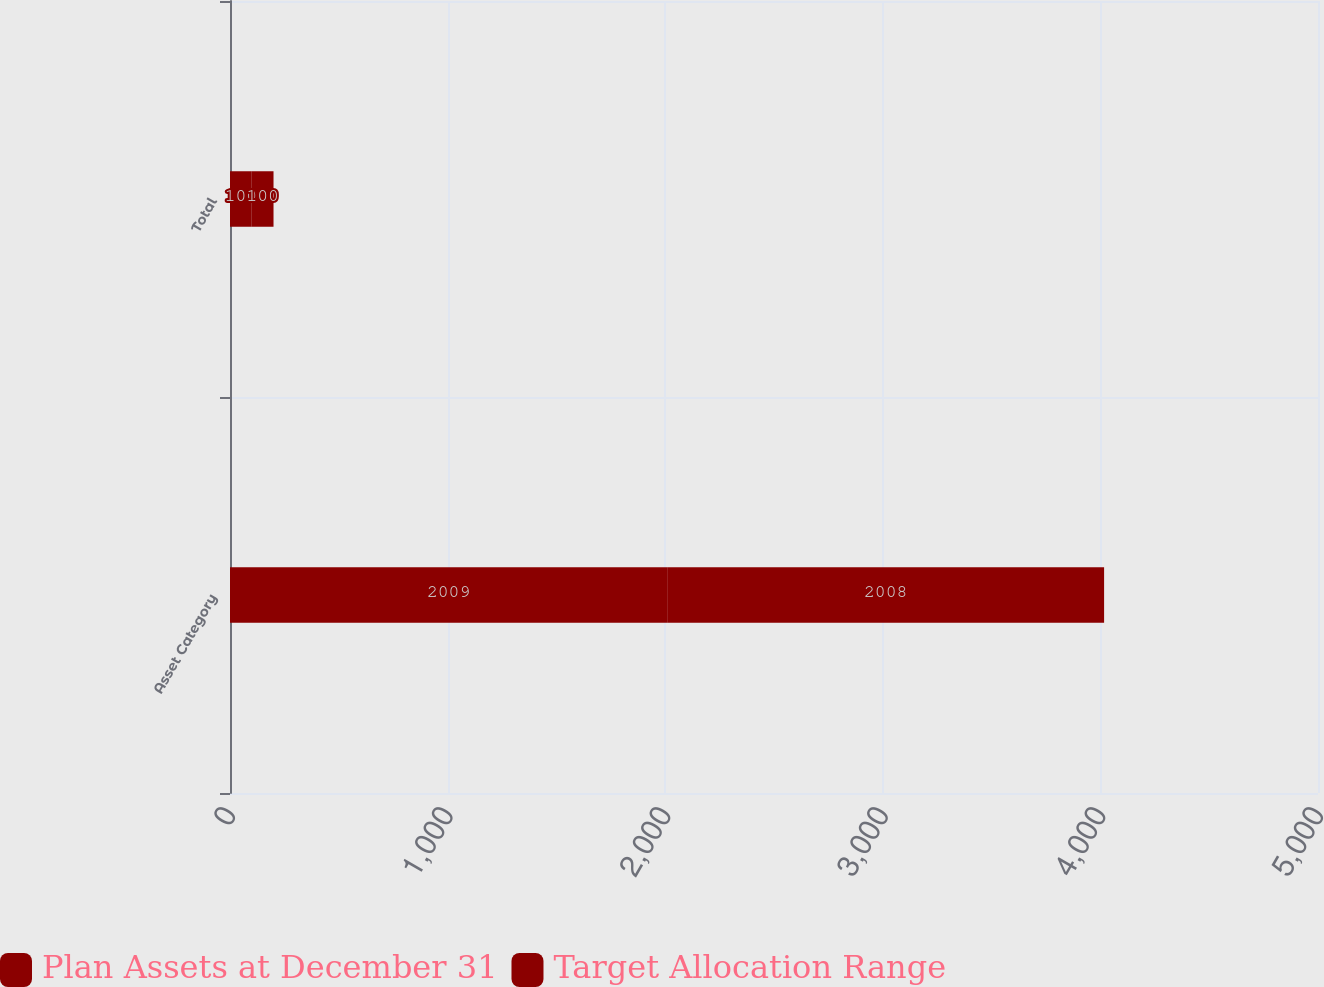Convert chart to OTSL. <chart><loc_0><loc_0><loc_500><loc_500><stacked_bar_chart><ecel><fcel>Asset Category<fcel>Total<nl><fcel>Plan Assets at December 31<fcel>2009<fcel>100<nl><fcel>Target Allocation Range<fcel>2008<fcel>100<nl></chart> 